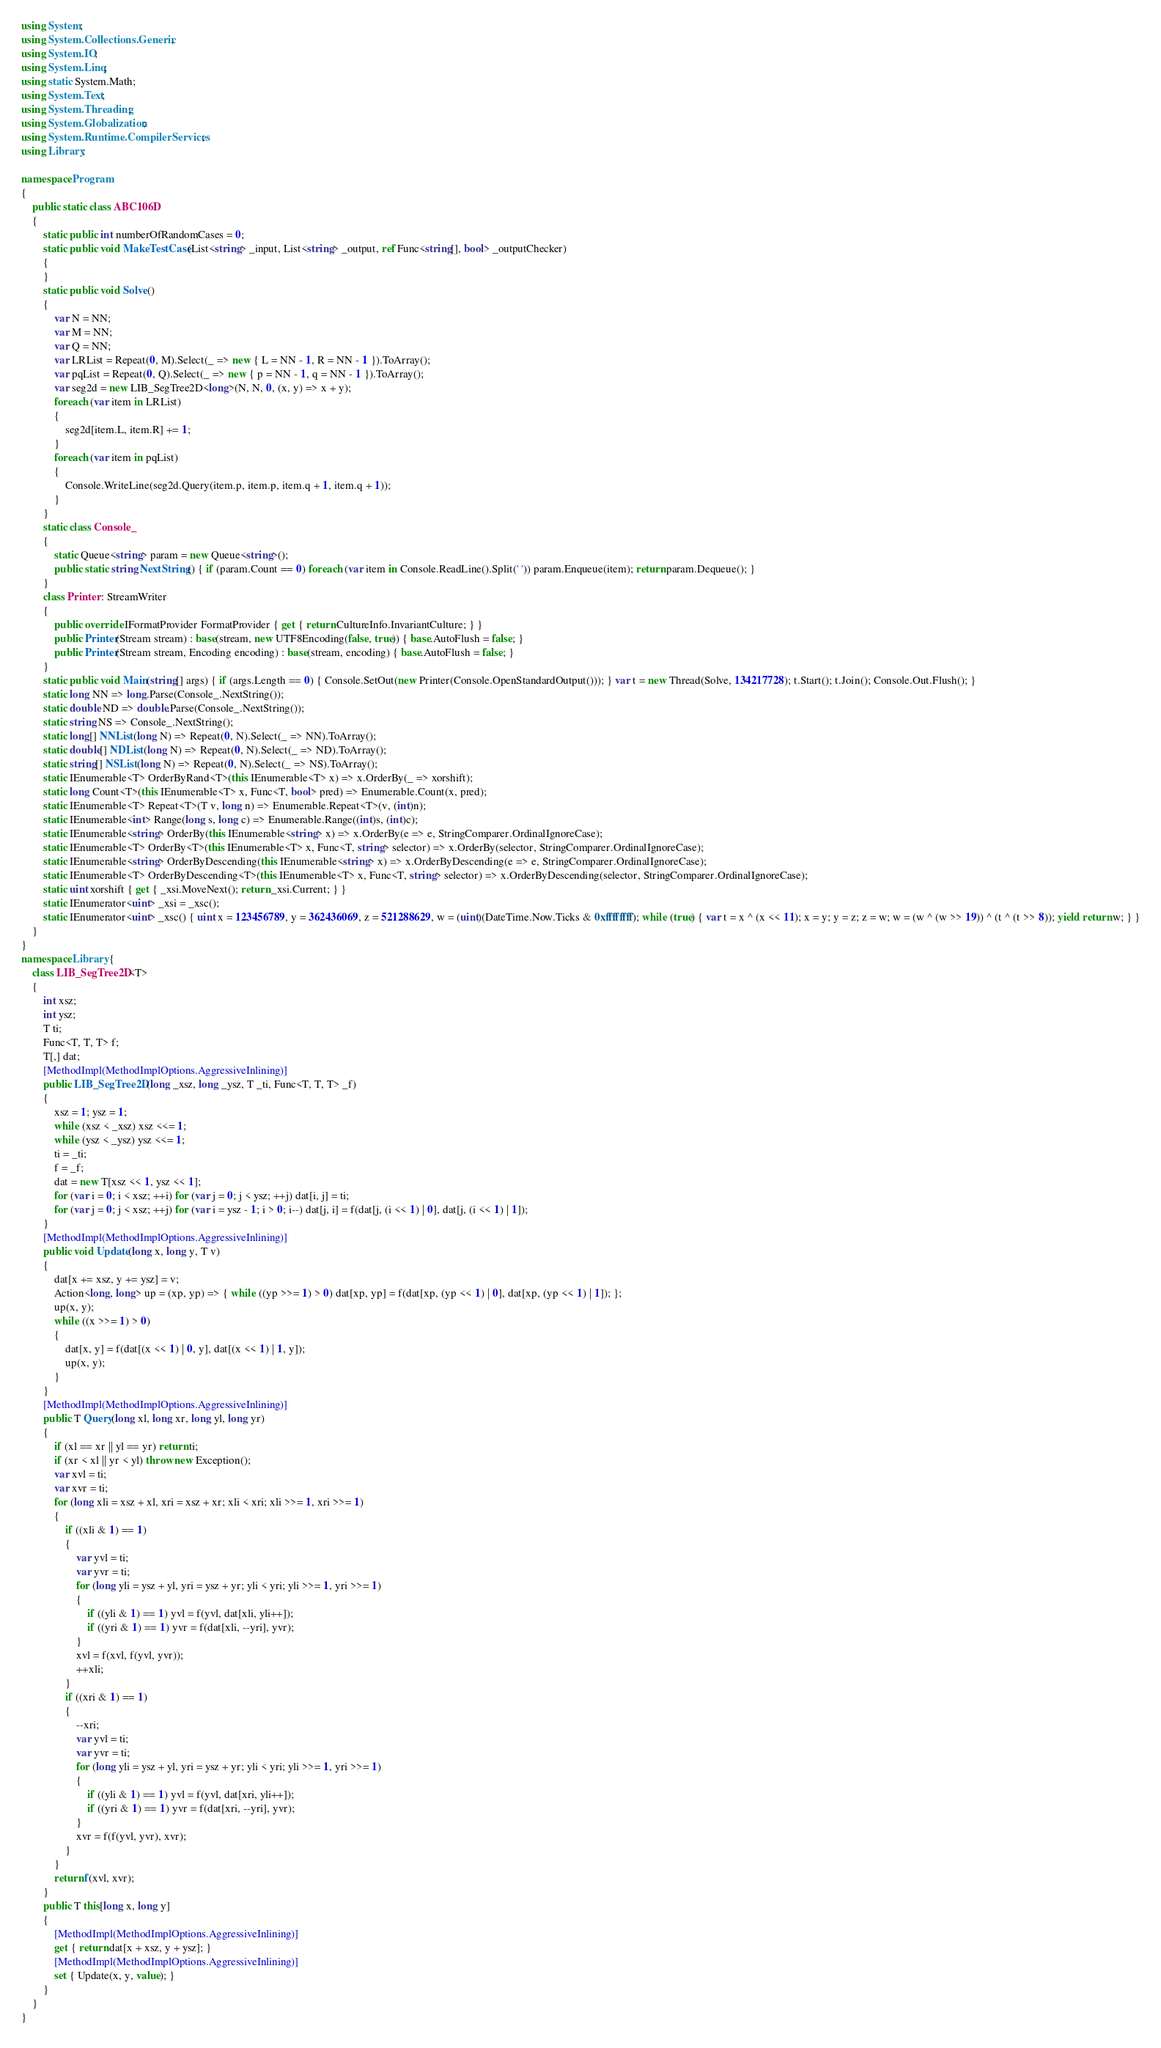<code> <loc_0><loc_0><loc_500><loc_500><_C#_>using System;
using System.Collections.Generic;
using System.IO;
using System.Linq;
using static System.Math;
using System.Text;
using System.Threading;
using System.Globalization;
using System.Runtime.CompilerServices;
using Library;

namespace Program
{
    public static class ABC106D
    {
        static public int numberOfRandomCases = 0;
        static public void MakeTestCase(List<string> _input, List<string> _output, ref Func<string[], bool> _outputChecker)
        {
        }
        static public void Solve()
        {
            var N = NN;
            var M = NN;
            var Q = NN;
            var LRList = Repeat(0, M).Select(_ => new { L = NN - 1, R = NN - 1 }).ToArray();
            var pqList = Repeat(0, Q).Select(_ => new { p = NN - 1, q = NN - 1 }).ToArray();
            var seg2d = new LIB_SegTree2D<long>(N, N, 0, (x, y) => x + y);
            foreach (var item in LRList)
            {
                seg2d[item.L, item.R] += 1;
            }
            foreach (var item in pqList)
            {
                Console.WriteLine(seg2d.Query(item.p, item.p, item.q + 1, item.q + 1));
            }
        }
        static class Console_
        {
            static Queue<string> param = new Queue<string>();
            public static string NextString() { if (param.Count == 0) foreach (var item in Console.ReadLine().Split(' ')) param.Enqueue(item); return param.Dequeue(); }
        }
        class Printer : StreamWriter
        {
            public override IFormatProvider FormatProvider { get { return CultureInfo.InvariantCulture; } }
            public Printer(Stream stream) : base(stream, new UTF8Encoding(false, true)) { base.AutoFlush = false; }
            public Printer(Stream stream, Encoding encoding) : base(stream, encoding) { base.AutoFlush = false; }
        }
        static public void Main(string[] args) { if (args.Length == 0) { Console.SetOut(new Printer(Console.OpenStandardOutput())); } var t = new Thread(Solve, 134217728); t.Start(); t.Join(); Console.Out.Flush(); }
        static long NN => long.Parse(Console_.NextString());
        static double ND => double.Parse(Console_.NextString());
        static string NS => Console_.NextString();
        static long[] NNList(long N) => Repeat(0, N).Select(_ => NN).ToArray();
        static double[] NDList(long N) => Repeat(0, N).Select(_ => ND).ToArray();
        static string[] NSList(long N) => Repeat(0, N).Select(_ => NS).ToArray();
        static IEnumerable<T> OrderByRand<T>(this IEnumerable<T> x) => x.OrderBy(_ => xorshift);
        static long Count<T>(this IEnumerable<T> x, Func<T, bool> pred) => Enumerable.Count(x, pred);
        static IEnumerable<T> Repeat<T>(T v, long n) => Enumerable.Repeat<T>(v, (int)n);
        static IEnumerable<int> Range(long s, long c) => Enumerable.Range((int)s, (int)c);
        static IEnumerable<string> OrderBy(this IEnumerable<string> x) => x.OrderBy(e => e, StringComparer.OrdinalIgnoreCase);
        static IEnumerable<T> OrderBy<T>(this IEnumerable<T> x, Func<T, string> selector) => x.OrderBy(selector, StringComparer.OrdinalIgnoreCase);
        static IEnumerable<string> OrderByDescending(this IEnumerable<string> x) => x.OrderByDescending(e => e, StringComparer.OrdinalIgnoreCase);
        static IEnumerable<T> OrderByDescending<T>(this IEnumerable<T> x, Func<T, string> selector) => x.OrderByDescending(selector, StringComparer.OrdinalIgnoreCase);
        static uint xorshift { get { _xsi.MoveNext(); return _xsi.Current; } }
        static IEnumerator<uint> _xsi = _xsc();
        static IEnumerator<uint> _xsc() { uint x = 123456789, y = 362436069, z = 521288629, w = (uint)(DateTime.Now.Ticks & 0xffffffff); while (true) { var t = x ^ (x << 11); x = y; y = z; z = w; w = (w ^ (w >> 19)) ^ (t ^ (t >> 8)); yield return w; } }
    }
}
namespace Library {
    class LIB_SegTree2D<T>
    {
        int xsz;
        int ysz;
        T ti;
        Func<T, T, T> f;
        T[,] dat;
        [MethodImpl(MethodImplOptions.AggressiveInlining)]
        public LIB_SegTree2D(long _xsz, long _ysz, T _ti, Func<T, T, T> _f)
        {
            xsz = 1; ysz = 1;
            while (xsz < _xsz) xsz <<= 1;
            while (ysz < _ysz) ysz <<= 1;
            ti = _ti;
            f = _f;
            dat = new T[xsz << 1, ysz << 1];
            for (var i = 0; i < xsz; ++i) for (var j = 0; j < ysz; ++j) dat[i, j] = ti;
            for (var j = 0; j < xsz; ++j) for (var i = ysz - 1; i > 0; i--) dat[j, i] = f(dat[j, (i << 1) | 0], dat[j, (i << 1) | 1]);
        }
        [MethodImpl(MethodImplOptions.AggressiveInlining)]
        public void Update(long x, long y, T v)
        {
            dat[x += xsz, y += ysz] = v;
            Action<long, long> up = (xp, yp) => { while ((yp >>= 1) > 0) dat[xp, yp] = f(dat[xp, (yp << 1) | 0], dat[xp, (yp << 1) | 1]); };
            up(x, y);
            while ((x >>= 1) > 0)
            {
                dat[x, y] = f(dat[(x << 1) | 0, y], dat[(x << 1) | 1, y]);
                up(x, y);
            }
        }
        [MethodImpl(MethodImplOptions.AggressiveInlining)]
        public T Query(long xl, long xr, long yl, long yr)
        {
            if (xl == xr || yl == yr) return ti;
            if (xr < xl || yr < yl) throw new Exception();
            var xvl = ti;
            var xvr = ti;
            for (long xli = xsz + xl, xri = xsz + xr; xli < xri; xli >>= 1, xri >>= 1)
            {
                if ((xli & 1) == 1)
                {
                    var yvl = ti;
                    var yvr = ti;
                    for (long yli = ysz + yl, yri = ysz + yr; yli < yri; yli >>= 1, yri >>= 1)
                    {
                        if ((yli & 1) == 1) yvl = f(yvl, dat[xli, yli++]);
                        if ((yri & 1) == 1) yvr = f(dat[xli, --yri], yvr);
                    }
                    xvl = f(xvl, f(yvl, yvr));
                    ++xli;
                }
                if ((xri & 1) == 1)
                {
                    --xri;
                    var yvl = ti;
                    var yvr = ti;
                    for (long yli = ysz + yl, yri = ysz + yr; yli < yri; yli >>= 1, yri >>= 1)
                    {
                        if ((yli & 1) == 1) yvl = f(yvl, dat[xri, yli++]);
                        if ((yri & 1) == 1) yvr = f(dat[xri, --yri], yvr);
                    }
                    xvr = f(f(yvl, yvr), xvr);
                }
            }
            return f(xvl, xvr);
        }
        public T this[long x, long y]
        {
            [MethodImpl(MethodImplOptions.AggressiveInlining)]
            get { return dat[x + xsz, y + ysz]; }
            [MethodImpl(MethodImplOptions.AggressiveInlining)]
            set { Update(x, y, value); }
        }
    }
}
</code> 